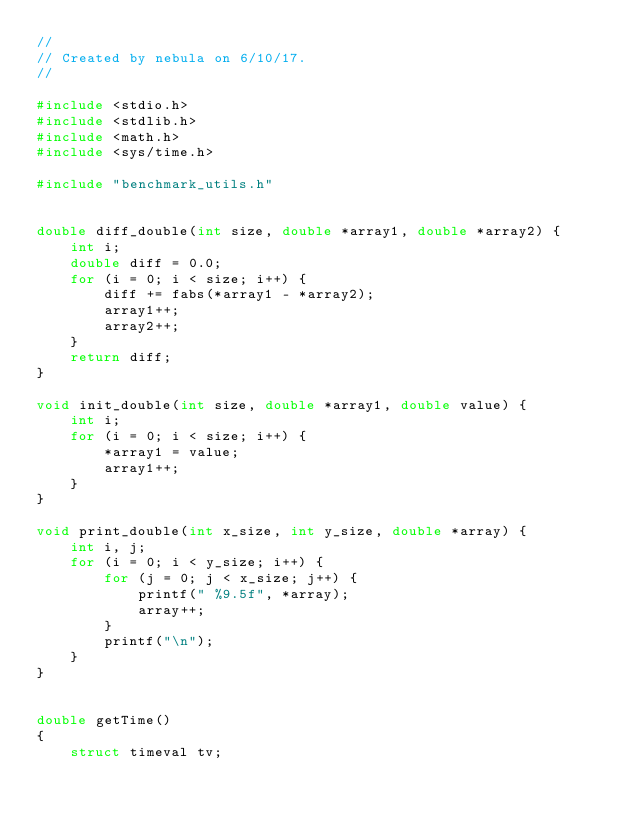Convert code to text. <code><loc_0><loc_0><loc_500><loc_500><_C_>//
// Created by nebula on 6/10/17.
//

#include <stdio.h>
#include <stdlib.h>
#include <math.h>
#include <sys/time.h>

#include "benchmark_utils.h"


double diff_double(int size, double *array1, double *array2) {
    int i;
    double diff = 0.0;
    for (i = 0; i < size; i++) {
        diff += fabs(*array1 - *array2);
        array1++;
        array2++;
    }
    return diff;
}

void init_double(int size, double *array1, double value) {
    int i;
    for (i = 0; i < size; i++) {
        *array1 = value;
        array1++;
    }
}

void print_double(int x_size, int y_size, double *array) {
    int i, j;
    for (i = 0; i < y_size; i++) {
        for (j = 0; j < x_size; j++) {
            printf(" %9.5f", *array);
            array++;
        }
        printf("\n");
    }
}


double getTime()
{
    struct timeval tv;</code> 